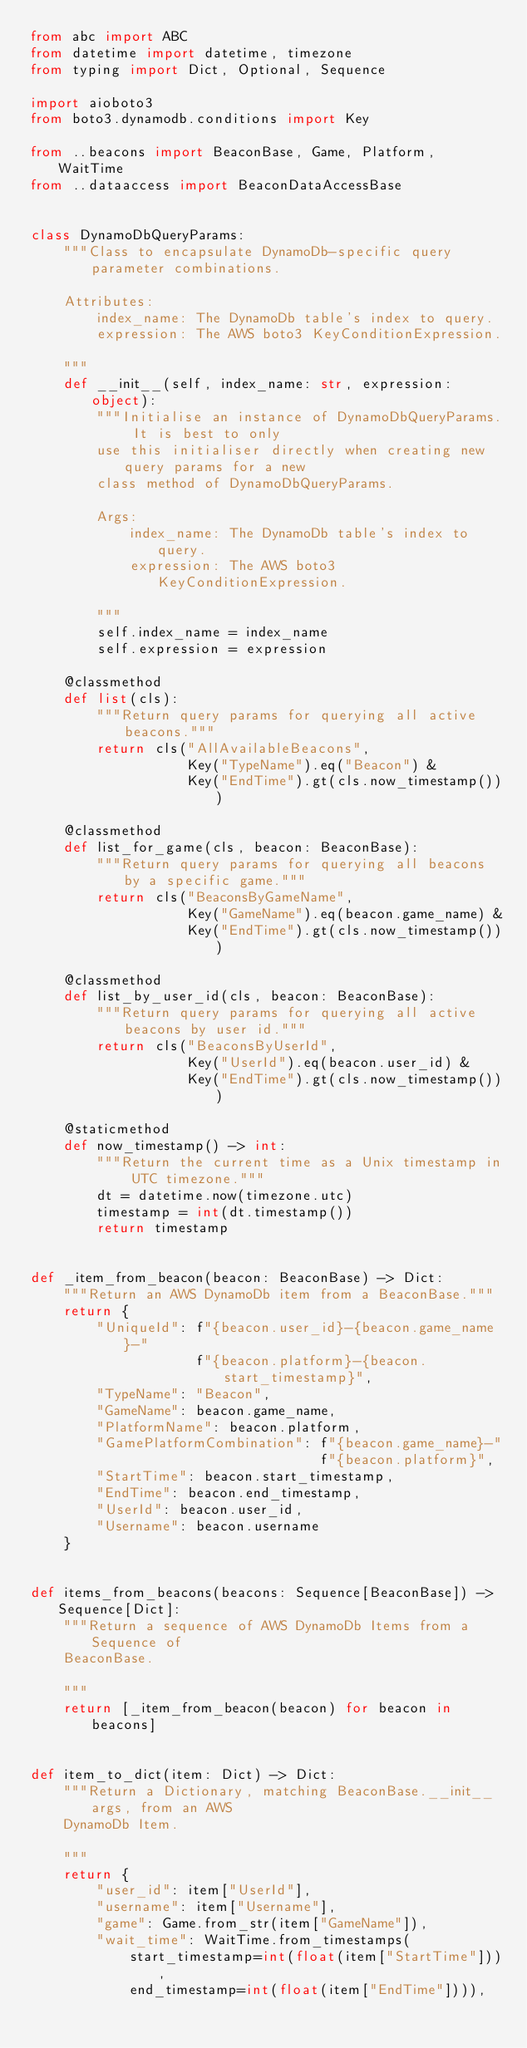<code> <loc_0><loc_0><loc_500><loc_500><_Python_>from abc import ABC
from datetime import datetime, timezone
from typing import Dict, Optional, Sequence

import aioboto3
from boto3.dynamodb.conditions import Key

from ..beacons import BeaconBase, Game, Platform, WaitTime
from ..dataaccess import BeaconDataAccessBase


class DynamoDbQueryParams:
    """Class to encapsulate DynamoDb-specific query parameter combinations.

    Attributes:
        index_name: The DynamoDb table's index to query.
        expression: The AWS boto3 KeyConditionExpression.

    """
    def __init__(self, index_name: str, expression: object):
        """Initialise an instance of DynamoDbQueryParams. It is best to only
        use this initialiser directly when creating new query params for a new
        class method of DynamoDbQueryParams.

        Args:
            index_name: The DynamoDb table's index to query.
            expression: The AWS boto3 KeyConditionExpression.

        """
        self.index_name = index_name
        self.expression = expression

    @classmethod
    def list(cls):
        """Return query params for querying all active beacons."""
        return cls("AllAvailableBeacons",
                   Key("TypeName").eq("Beacon") &
                   Key("EndTime").gt(cls.now_timestamp()))

    @classmethod
    def list_for_game(cls, beacon: BeaconBase):
        """Return query params for querying all beacons by a specific game."""
        return cls("BeaconsByGameName",
                   Key("GameName").eq(beacon.game_name) &
                   Key("EndTime").gt(cls.now_timestamp()))

    @classmethod
    def list_by_user_id(cls, beacon: BeaconBase):
        """Return query params for querying all active beacons by user id."""
        return cls("BeaconsByUserId",
                   Key("UserId").eq(beacon.user_id) &
                   Key("EndTime").gt(cls.now_timestamp()))

    @staticmethod
    def now_timestamp() -> int:
        """Return the current time as a Unix timestamp in UTC timezone."""
        dt = datetime.now(timezone.utc)
        timestamp = int(dt.timestamp())
        return timestamp


def _item_from_beacon(beacon: BeaconBase) -> Dict:
    """Return an AWS DynamoDb item from a BeaconBase."""
    return {
        "UniqueId": f"{beacon.user_id}-{beacon.game_name}-"
                    f"{beacon.platform}-{beacon.start_timestamp}",
        "TypeName": "Beacon",
        "GameName": beacon.game_name,
        "PlatformName": beacon.platform,
        "GamePlatformCombination": f"{beacon.game_name}-"
                                   f"{beacon.platform}",
        "StartTime": beacon.start_timestamp,
        "EndTime": beacon.end_timestamp,
        "UserId": beacon.user_id,
        "Username": beacon.username
    }


def items_from_beacons(beacons: Sequence[BeaconBase]) -> Sequence[Dict]:
    """Return a sequence of AWS DynamoDb Items from a Sequence of
    BeaconBase.

    """
    return [_item_from_beacon(beacon) for beacon in beacons]


def item_to_dict(item: Dict) -> Dict:
    """Return a Dictionary, matching BeaconBase.__init__ args, from an AWS
    DynamoDb Item.

    """
    return {
        "user_id": item["UserId"],
        "username": item["Username"],
        "game": Game.from_str(item["GameName"]),
        "wait_time": WaitTime.from_timestamps(
            start_timestamp=int(float(item["StartTime"])),
            end_timestamp=int(float(item["EndTime"]))),</code> 